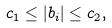<formula> <loc_0><loc_0><loc_500><loc_500>\\ c _ { 1 } \leq | b _ { i } | \leq c _ { 2 } ,</formula> 